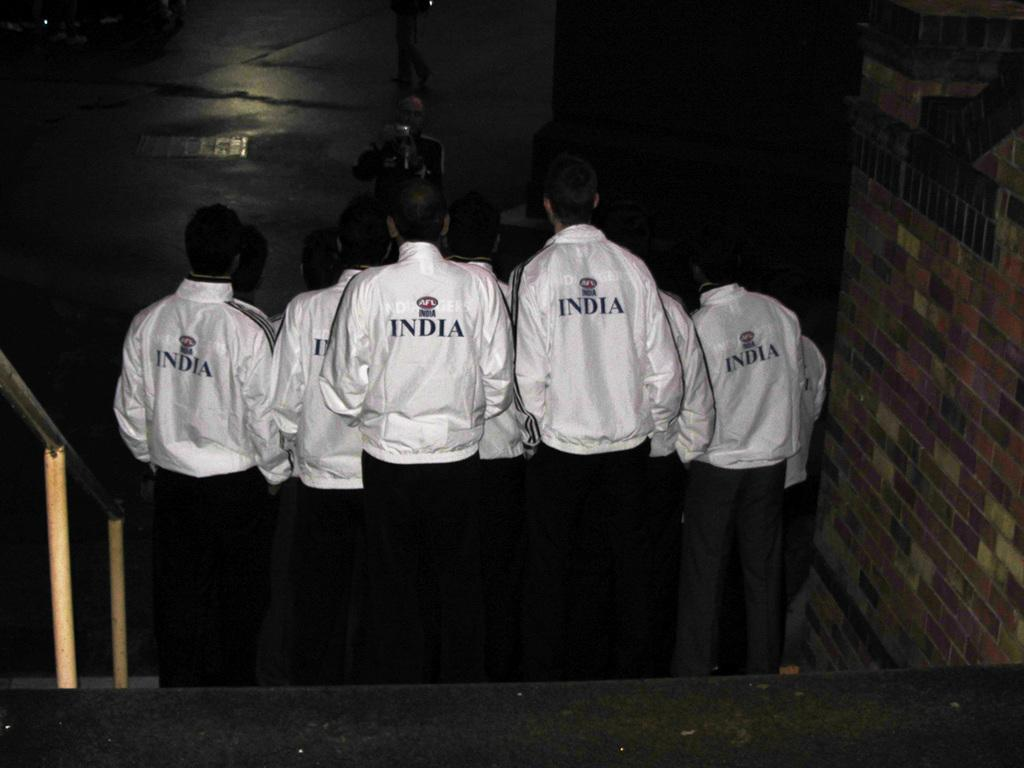<image>
Provide a brief description of the given image. a few people with jackets on that say India on it 